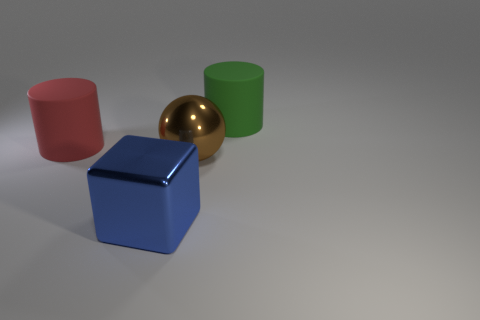How big is the green object?
Offer a very short reply. Large. Are there any large rubber spheres?
Make the answer very short. No. Is the material of the large cylinder on the left side of the big metal ball the same as the green thing?
Keep it short and to the point. Yes. There is a big red thing that is the same shape as the big green rubber object; what is it made of?
Your answer should be very brief. Rubber. Is the number of purple matte cylinders less than the number of large red matte things?
Offer a terse response. Yes. What is the color of the large thing that is the same material as the large green cylinder?
Keep it short and to the point. Red. What is the large brown thing made of?
Provide a succinct answer. Metal. What is the material of the brown object that is the same size as the blue metallic thing?
Your answer should be compact. Metal. Are there any blue things that have the same size as the red cylinder?
Provide a short and direct response. Yes. Are there the same number of rubber objects left of the large red matte cylinder and large metallic spheres right of the large shiny sphere?
Ensure brevity in your answer.  Yes. 